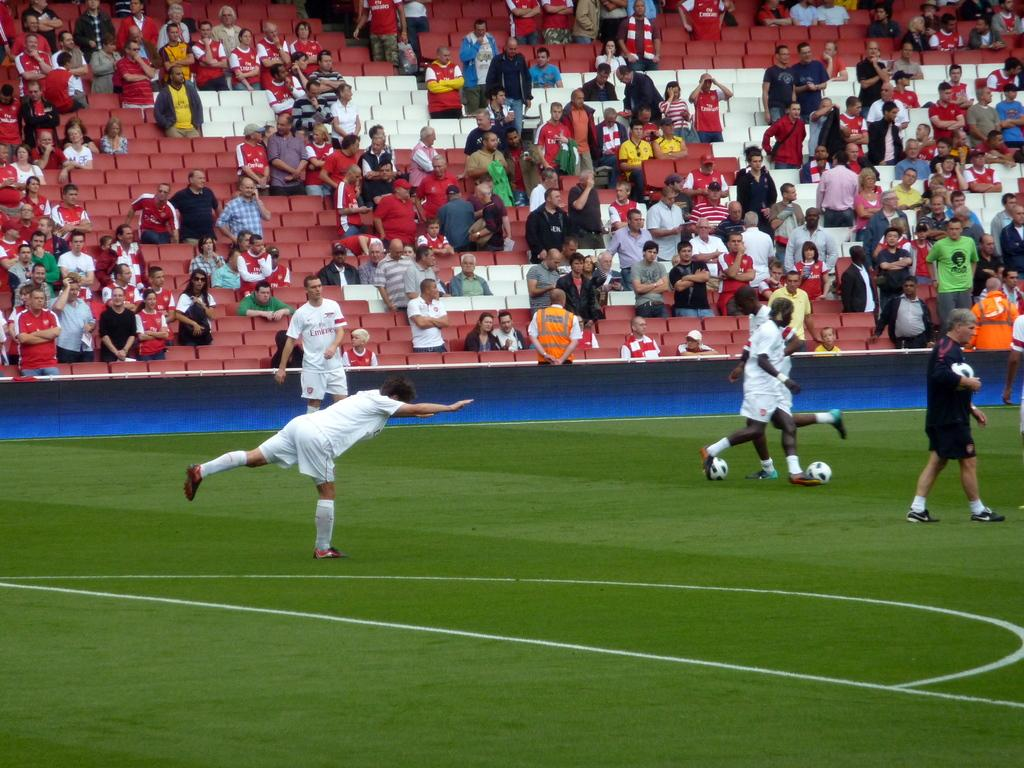<image>
Describe the image concisely. Men are playing soccer and one team is the Emirates. 